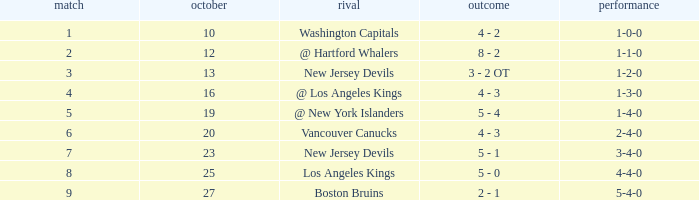What was the average game with a record of 4-4-0? 8.0. 